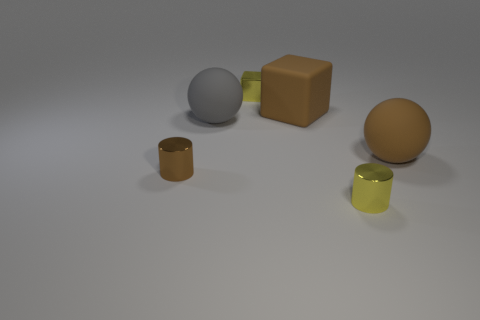How many other things are the same shape as the small brown thing? Including the small brown cylinder on the left, there are two objects with a cylindrical shape in the image. The other is the taller, lime-green cylinder on the right. 